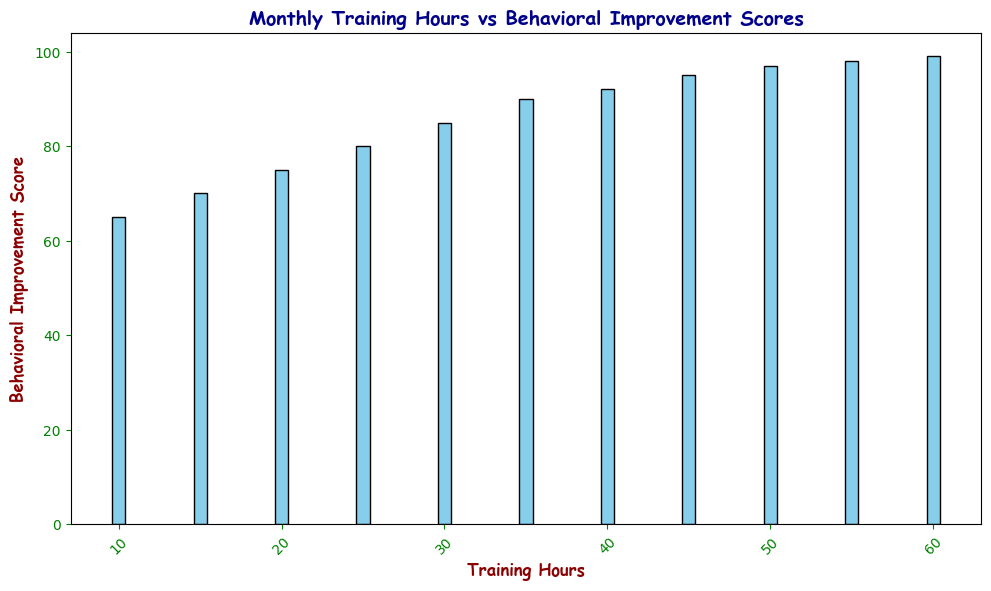How many total training hours are represented in the figure? Sum the training hours: 10 + 15 + 20 + 25 + 30 + 35 + 40 + 45 + 50 + 55 + 60
Answer: 385 Which training hours have the highest behavioral improvement score and what is the score? The highest bar visually, representing 60 training hours has the highest behavioral improvement score of 99
Answer: 60 hours, 99 What is the difference in behavioral improvement scores between 25 training hours and 55 training hours? Find the scores for both points: 80 (for 25 hours) and 98 (for 55 hours). Subtract the score at 25 hours from the score at 55 hours: 98 - 80
Answer: 18 What is the average behavioral improvement score for the shown data? Sum the scores (65+70+75+80+85+90+92+95+97+98+99 = 946) and divide by the number of points (11): 946 / 11
Answer: 86 Which training hours show a behavioral improvement score greater than 90? Identify scores greater than 90: 92 (40 hours), 95 (45 hours), 97 (50 hours), 98 (55 hours), 99 (60 hours)
Answer: 40, 45, 50, 55, 60 hours Is there a noticeable trend in the relationship between training hours and behavioral improvement scores? As training hours increase, behavioral improvement scores also increase, indicating a positive correlation. This pattern is visible throughout the bars
Answer: Yes What is the median behavioral improvement score and which training hours does it correspond to? Order the scores: 65, 70, 75, 80, 85, 90, 92, 95, 97, 98, 99. The middle value (6th score) is 90, corresponding to 35 training hours
Answer: 90, 35 hours Which training hours show an improvement score less than 80? Identify scores less than 80: 65 (10 hours), 70 (15 hours), 75 (20 hours)
Answer: 10, 15, 20 hours 